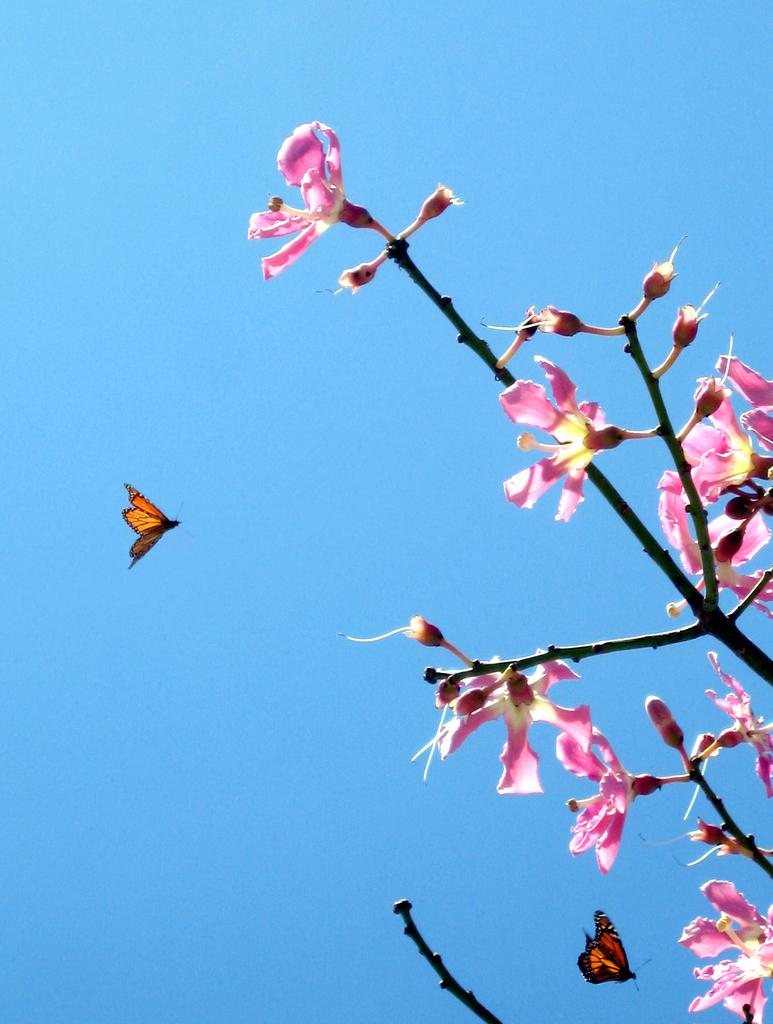What type of flowers can be seen in the image? There are pink flowers in the image. What other living creatures are present in the image? There are 2 butterflies flying in the sky in the image. What type of rhythm can be heard from the deer in the image? There are no deer present in the image, so there is no rhythm to be heard. What sound does the whistle make in the image? There is no whistle present in the image, so no sound can be heard. 